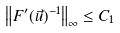Convert formula to latex. <formula><loc_0><loc_0><loc_500><loc_500>\left \| F ^ { \prime } ( \vec { u } ) ^ { - 1 } \right \| _ { \infty } \leq C _ { 1 }</formula> 